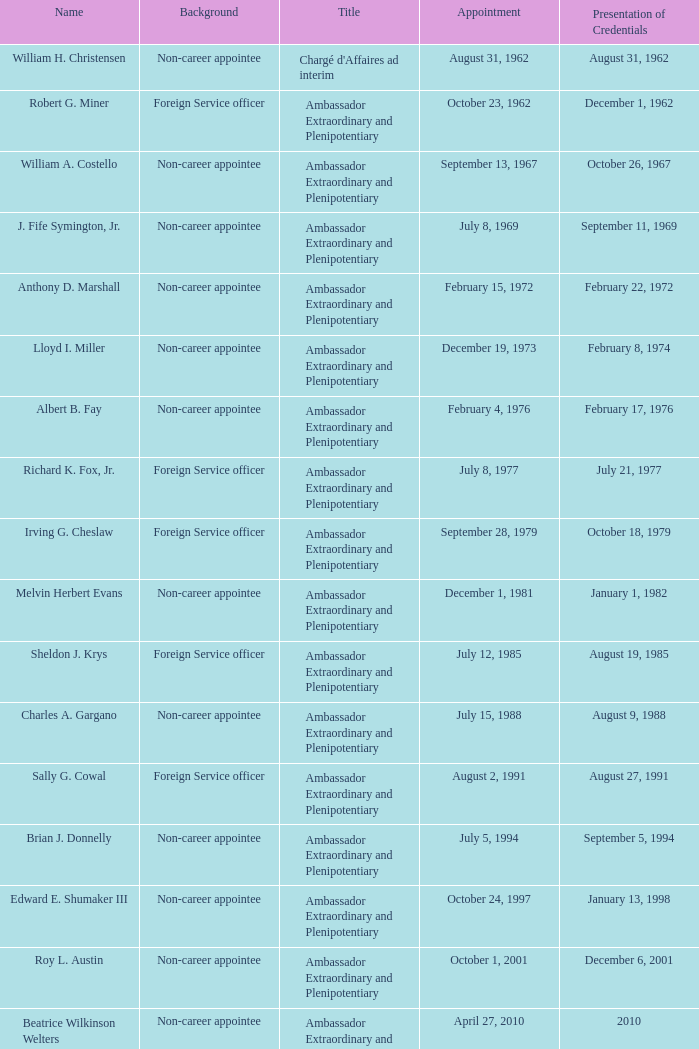At an unspecified date, who submitted their credentials? Margaret B. Diop. 